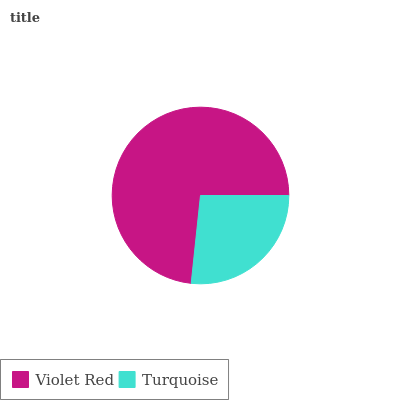Is Turquoise the minimum?
Answer yes or no. Yes. Is Violet Red the maximum?
Answer yes or no. Yes. Is Turquoise the maximum?
Answer yes or no. No. Is Violet Red greater than Turquoise?
Answer yes or no. Yes. Is Turquoise less than Violet Red?
Answer yes or no. Yes. Is Turquoise greater than Violet Red?
Answer yes or no. No. Is Violet Red less than Turquoise?
Answer yes or no. No. Is Violet Red the high median?
Answer yes or no. Yes. Is Turquoise the low median?
Answer yes or no. Yes. Is Turquoise the high median?
Answer yes or no. No. Is Violet Red the low median?
Answer yes or no. No. 